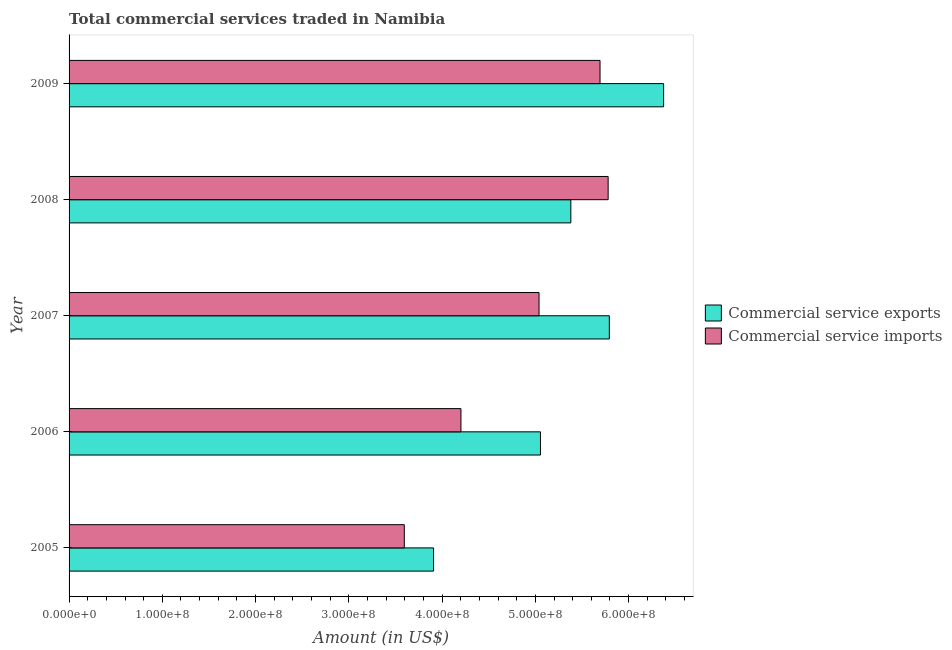How many groups of bars are there?
Offer a terse response. 5. Are the number of bars per tick equal to the number of legend labels?
Your answer should be very brief. Yes. How many bars are there on the 3rd tick from the top?
Offer a very short reply. 2. How many bars are there on the 5th tick from the bottom?
Ensure brevity in your answer.  2. What is the label of the 2nd group of bars from the top?
Make the answer very short. 2008. What is the amount of commercial service imports in 2009?
Keep it short and to the point. 5.69e+08. Across all years, what is the maximum amount of commercial service exports?
Offer a very short reply. 6.38e+08. Across all years, what is the minimum amount of commercial service imports?
Provide a succinct answer. 3.59e+08. In which year was the amount of commercial service imports maximum?
Provide a short and direct response. 2008. What is the total amount of commercial service exports in the graph?
Your response must be concise. 2.65e+09. What is the difference between the amount of commercial service exports in 2005 and that in 2009?
Make the answer very short. -2.47e+08. What is the difference between the amount of commercial service imports in 2008 and the amount of commercial service exports in 2009?
Provide a short and direct response. -5.95e+07. What is the average amount of commercial service exports per year?
Your answer should be compact. 5.30e+08. In the year 2005, what is the difference between the amount of commercial service exports and amount of commercial service imports?
Ensure brevity in your answer.  3.14e+07. In how many years, is the amount of commercial service imports greater than 260000000 US$?
Offer a terse response. 5. What is the ratio of the amount of commercial service exports in 2006 to that in 2007?
Keep it short and to the point. 0.87. What is the difference between the highest and the second highest amount of commercial service imports?
Keep it short and to the point. 8.69e+06. What is the difference between the highest and the lowest amount of commercial service imports?
Offer a terse response. 2.19e+08. In how many years, is the amount of commercial service imports greater than the average amount of commercial service imports taken over all years?
Give a very brief answer. 3. What does the 2nd bar from the top in 2005 represents?
Keep it short and to the point. Commercial service exports. What does the 1st bar from the bottom in 2007 represents?
Offer a terse response. Commercial service exports. How many bars are there?
Your response must be concise. 10. How many years are there in the graph?
Keep it short and to the point. 5. What is the difference between two consecutive major ticks on the X-axis?
Make the answer very short. 1.00e+08. Are the values on the major ticks of X-axis written in scientific E-notation?
Offer a terse response. Yes. Does the graph contain any zero values?
Keep it short and to the point. No. Does the graph contain grids?
Keep it short and to the point. No. Where does the legend appear in the graph?
Offer a terse response. Center right. How many legend labels are there?
Give a very brief answer. 2. What is the title of the graph?
Ensure brevity in your answer.  Total commercial services traded in Namibia. What is the label or title of the X-axis?
Your answer should be very brief. Amount (in US$). What is the Amount (in US$) of Commercial service exports in 2005?
Your response must be concise. 3.91e+08. What is the Amount (in US$) of Commercial service imports in 2005?
Your response must be concise. 3.59e+08. What is the Amount (in US$) in Commercial service exports in 2006?
Offer a terse response. 5.05e+08. What is the Amount (in US$) in Commercial service imports in 2006?
Give a very brief answer. 4.20e+08. What is the Amount (in US$) in Commercial service exports in 2007?
Keep it short and to the point. 5.79e+08. What is the Amount (in US$) of Commercial service imports in 2007?
Make the answer very short. 5.04e+08. What is the Amount (in US$) of Commercial service exports in 2008?
Give a very brief answer. 5.38e+08. What is the Amount (in US$) of Commercial service imports in 2008?
Keep it short and to the point. 5.78e+08. What is the Amount (in US$) in Commercial service exports in 2009?
Your answer should be very brief. 6.38e+08. What is the Amount (in US$) of Commercial service imports in 2009?
Ensure brevity in your answer.  5.69e+08. Across all years, what is the maximum Amount (in US$) in Commercial service exports?
Provide a short and direct response. 6.38e+08. Across all years, what is the maximum Amount (in US$) in Commercial service imports?
Your answer should be compact. 5.78e+08. Across all years, what is the minimum Amount (in US$) in Commercial service exports?
Offer a very short reply. 3.91e+08. Across all years, what is the minimum Amount (in US$) in Commercial service imports?
Ensure brevity in your answer.  3.59e+08. What is the total Amount (in US$) of Commercial service exports in the graph?
Make the answer very short. 2.65e+09. What is the total Amount (in US$) of Commercial service imports in the graph?
Keep it short and to the point. 2.43e+09. What is the difference between the Amount (in US$) of Commercial service exports in 2005 and that in 2006?
Your answer should be very brief. -1.15e+08. What is the difference between the Amount (in US$) in Commercial service imports in 2005 and that in 2006?
Provide a short and direct response. -6.07e+07. What is the difference between the Amount (in US$) in Commercial service exports in 2005 and that in 2007?
Make the answer very short. -1.88e+08. What is the difference between the Amount (in US$) of Commercial service imports in 2005 and that in 2007?
Offer a terse response. -1.44e+08. What is the difference between the Amount (in US$) of Commercial service exports in 2005 and that in 2008?
Your answer should be very brief. -1.47e+08. What is the difference between the Amount (in US$) in Commercial service imports in 2005 and that in 2008?
Your response must be concise. -2.19e+08. What is the difference between the Amount (in US$) in Commercial service exports in 2005 and that in 2009?
Your answer should be compact. -2.47e+08. What is the difference between the Amount (in US$) of Commercial service imports in 2005 and that in 2009?
Offer a terse response. -2.10e+08. What is the difference between the Amount (in US$) in Commercial service exports in 2006 and that in 2007?
Provide a succinct answer. -7.38e+07. What is the difference between the Amount (in US$) of Commercial service imports in 2006 and that in 2007?
Provide a succinct answer. -8.37e+07. What is the difference between the Amount (in US$) in Commercial service exports in 2006 and that in 2008?
Your answer should be very brief. -3.26e+07. What is the difference between the Amount (in US$) in Commercial service imports in 2006 and that in 2008?
Give a very brief answer. -1.58e+08. What is the difference between the Amount (in US$) of Commercial service exports in 2006 and that in 2009?
Offer a terse response. -1.32e+08. What is the difference between the Amount (in US$) of Commercial service imports in 2006 and that in 2009?
Provide a short and direct response. -1.49e+08. What is the difference between the Amount (in US$) of Commercial service exports in 2007 and that in 2008?
Give a very brief answer. 4.13e+07. What is the difference between the Amount (in US$) of Commercial service imports in 2007 and that in 2008?
Ensure brevity in your answer.  -7.41e+07. What is the difference between the Amount (in US$) of Commercial service exports in 2007 and that in 2009?
Make the answer very short. -5.82e+07. What is the difference between the Amount (in US$) in Commercial service imports in 2007 and that in 2009?
Your answer should be compact. -6.54e+07. What is the difference between the Amount (in US$) of Commercial service exports in 2008 and that in 2009?
Provide a short and direct response. -9.95e+07. What is the difference between the Amount (in US$) in Commercial service imports in 2008 and that in 2009?
Your answer should be very brief. 8.69e+06. What is the difference between the Amount (in US$) of Commercial service exports in 2005 and the Amount (in US$) of Commercial service imports in 2006?
Provide a succinct answer. -2.93e+07. What is the difference between the Amount (in US$) in Commercial service exports in 2005 and the Amount (in US$) in Commercial service imports in 2007?
Your answer should be very brief. -1.13e+08. What is the difference between the Amount (in US$) of Commercial service exports in 2005 and the Amount (in US$) of Commercial service imports in 2008?
Offer a terse response. -1.87e+08. What is the difference between the Amount (in US$) in Commercial service exports in 2005 and the Amount (in US$) in Commercial service imports in 2009?
Your answer should be compact. -1.78e+08. What is the difference between the Amount (in US$) of Commercial service exports in 2006 and the Amount (in US$) of Commercial service imports in 2007?
Offer a terse response. 1.54e+06. What is the difference between the Amount (in US$) in Commercial service exports in 2006 and the Amount (in US$) in Commercial service imports in 2008?
Your answer should be compact. -7.26e+07. What is the difference between the Amount (in US$) in Commercial service exports in 2006 and the Amount (in US$) in Commercial service imports in 2009?
Your response must be concise. -6.39e+07. What is the difference between the Amount (in US$) in Commercial service exports in 2007 and the Amount (in US$) in Commercial service imports in 2008?
Your response must be concise. 1.28e+06. What is the difference between the Amount (in US$) of Commercial service exports in 2007 and the Amount (in US$) of Commercial service imports in 2009?
Ensure brevity in your answer.  9.97e+06. What is the difference between the Amount (in US$) of Commercial service exports in 2008 and the Amount (in US$) of Commercial service imports in 2009?
Provide a succinct answer. -3.13e+07. What is the average Amount (in US$) of Commercial service exports per year?
Offer a very short reply. 5.30e+08. What is the average Amount (in US$) of Commercial service imports per year?
Provide a succinct answer. 4.86e+08. In the year 2005, what is the difference between the Amount (in US$) in Commercial service exports and Amount (in US$) in Commercial service imports?
Your response must be concise. 3.14e+07. In the year 2006, what is the difference between the Amount (in US$) of Commercial service exports and Amount (in US$) of Commercial service imports?
Give a very brief answer. 8.53e+07. In the year 2007, what is the difference between the Amount (in US$) in Commercial service exports and Amount (in US$) in Commercial service imports?
Provide a succinct answer. 7.54e+07. In the year 2008, what is the difference between the Amount (in US$) of Commercial service exports and Amount (in US$) of Commercial service imports?
Offer a terse response. -4.00e+07. In the year 2009, what is the difference between the Amount (in US$) in Commercial service exports and Amount (in US$) in Commercial service imports?
Provide a short and direct response. 6.82e+07. What is the ratio of the Amount (in US$) of Commercial service exports in 2005 to that in 2006?
Make the answer very short. 0.77. What is the ratio of the Amount (in US$) in Commercial service imports in 2005 to that in 2006?
Your response must be concise. 0.86. What is the ratio of the Amount (in US$) in Commercial service exports in 2005 to that in 2007?
Offer a very short reply. 0.67. What is the ratio of the Amount (in US$) of Commercial service imports in 2005 to that in 2007?
Your answer should be compact. 0.71. What is the ratio of the Amount (in US$) in Commercial service exports in 2005 to that in 2008?
Offer a terse response. 0.73. What is the ratio of the Amount (in US$) in Commercial service imports in 2005 to that in 2008?
Your answer should be very brief. 0.62. What is the ratio of the Amount (in US$) in Commercial service exports in 2005 to that in 2009?
Ensure brevity in your answer.  0.61. What is the ratio of the Amount (in US$) in Commercial service imports in 2005 to that in 2009?
Your response must be concise. 0.63. What is the ratio of the Amount (in US$) in Commercial service exports in 2006 to that in 2007?
Make the answer very short. 0.87. What is the ratio of the Amount (in US$) of Commercial service imports in 2006 to that in 2007?
Offer a very short reply. 0.83. What is the ratio of the Amount (in US$) in Commercial service exports in 2006 to that in 2008?
Offer a very short reply. 0.94. What is the ratio of the Amount (in US$) in Commercial service imports in 2006 to that in 2008?
Provide a succinct answer. 0.73. What is the ratio of the Amount (in US$) in Commercial service exports in 2006 to that in 2009?
Ensure brevity in your answer.  0.79. What is the ratio of the Amount (in US$) in Commercial service imports in 2006 to that in 2009?
Provide a short and direct response. 0.74. What is the ratio of the Amount (in US$) in Commercial service exports in 2007 to that in 2008?
Give a very brief answer. 1.08. What is the ratio of the Amount (in US$) in Commercial service imports in 2007 to that in 2008?
Give a very brief answer. 0.87. What is the ratio of the Amount (in US$) in Commercial service exports in 2007 to that in 2009?
Keep it short and to the point. 0.91. What is the ratio of the Amount (in US$) of Commercial service imports in 2007 to that in 2009?
Ensure brevity in your answer.  0.89. What is the ratio of the Amount (in US$) in Commercial service exports in 2008 to that in 2009?
Offer a terse response. 0.84. What is the ratio of the Amount (in US$) in Commercial service imports in 2008 to that in 2009?
Keep it short and to the point. 1.02. What is the difference between the highest and the second highest Amount (in US$) in Commercial service exports?
Offer a terse response. 5.82e+07. What is the difference between the highest and the second highest Amount (in US$) in Commercial service imports?
Your response must be concise. 8.69e+06. What is the difference between the highest and the lowest Amount (in US$) of Commercial service exports?
Your answer should be very brief. 2.47e+08. What is the difference between the highest and the lowest Amount (in US$) of Commercial service imports?
Keep it short and to the point. 2.19e+08. 